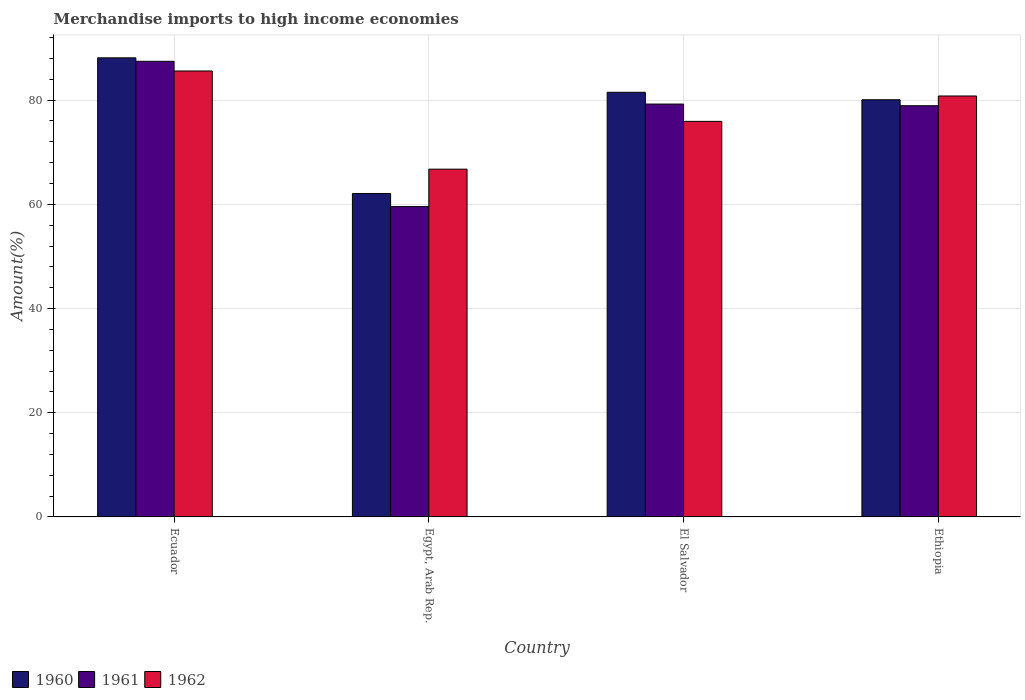Are the number of bars per tick equal to the number of legend labels?
Provide a short and direct response. Yes. Are the number of bars on each tick of the X-axis equal?
Provide a short and direct response. Yes. How many bars are there on the 2nd tick from the left?
Your answer should be very brief. 3. How many bars are there on the 4th tick from the right?
Your answer should be compact. 3. What is the label of the 4th group of bars from the left?
Give a very brief answer. Ethiopia. In how many cases, is the number of bars for a given country not equal to the number of legend labels?
Keep it short and to the point. 0. What is the percentage of amount earned from merchandise imports in 1960 in Egypt, Arab Rep.?
Your response must be concise. 62.08. Across all countries, what is the maximum percentage of amount earned from merchandise imports in 1962?
Provide a short and direct response. 85.59. Across all countries, what is the minimum percentage of amount earned from merchandise imports in 1961?
Ensure brevity in your answer.  59.56. In which country was the percentage of amount earned from merchandise imports in 1962 maximum?
Your answer should be compact. Ecuador. In which country was the percentage of amount earned from merchandise imports in 1962 minimum?
Your answer should be very brief. Egypt, Arab Rep. What is the total percentage of amount earned from merchandise imports in 1962 in the graph?
Provide a short and direct response. 309.06. What is the difference between the percentage of amount earned from merchandise imports in 1960 in El Salvador and that in Ethiopia?
Provide a short and direct response. 1.43. What is the difference between the percentage of amount earned from merchandise imports in 1960 in Ethiopia and the percentage of amount earned from merchandise imports in 1961 in El Salvador?
Provide a succinct answer. 0.83. What is the average percentage of amount earned from merchandise imports in 1960 per country?
Keep it short and to the point. 77.94. What is the difference between the percentage of amount earned from merchandise imports of/in 1961 and percentage of amount earned from merchandise imports of/in 1960 in El Salvador?
Provide a succinct answer. -2.26. In how many countries, is the percentage of amount earned from merchandise imports in 1960 greater than 72 %?
Offer a terse response. 3. What is the ratio of the percentage of amount earned from merchandise imports in 1962 in Ecuador to that in El Salvador?
Ensure brevity in your answer.  1.13. Is the difference between the percentage of amount earned from merchandise imports in 1961 in El Salvador and Ethiopia greater than the difference between the percentage of amount earned from merchandise imports in 1960 in El Salvador and Ethiopia?
Offer a terse response. No. What is the difference between the highest and the second highest percentage of amount earned from merchandise imports in 1960?
Provide a succinct answer. 6.61. What is the difference between the highest and the lowest percentage of amount earned from merchandise imports in 1962?
Your response must be concise. 18.84. What does the 3rd bar from the right in El Salvador represents?
Give a very brief answer. 1960. Are all the bars in the graph horizontal?
Provide a succinct answer. No. How many countries are there in the graph?
Your response must be concise. 4. What is the difference between two consecutive major ticks on the Y-axis?
Keep it short and to the point. 20. Are the values on the major ticks of Y-axis written in scientific E-notation?
Keep it short and to the point. No. Does the graph contain any zero values?
Your answer should be compact. No. Does the graph contain grids?
Provide a short and direct response. Yes. Where does the legend appear in the graph?
Your response must be concise. Bottom left. How many legend labels are there?
Provide a succinct answer. 3. How are the legend labels stacked?
Your answer should be very brief. Horizontal. What is the title of the graph?
Provide a succinct answer. Merchandise imports to high income economies. What is the label or title of the Y-axis?
Offer a terse response. Amount(%). What is the Amount(%) of 1960 in Ecuador?
Ensure brevity in your answer.  88.12. What is the Amount(%) of 1961 in Ecuador?
Offer a very short reply. 87.45. What is the Amount(%) of 1962 in Ecuador?
Offer a terse response. 85.59. What is the Amount(%) in 1960 in Egypt, Arab Rep.?
Provide a succinct answer. 62.08. What is the Amount(%) in 1961 in Egypt, Arab Rep.?
Offer a terse response. 59.56. What is the Amount(%) of 1962 in Egypt, Arab Rep.?
Offer a very short reply. 66.75. What is the Amount(%) of 1960 in El Salvador?
Your answer should be compact. 81.51. What is the Amount(%) in 1961 in El Salvador?
Ensure brevity in your answer.  79.24. What is the Amount(%) of 1962 in El Salvador?
Provide a succinct answer. 75.92. What is the Amount(%) in 1960 in Ethiopia?
Offer a very short reply. 80.07. What is the Amount(%) in 1961 in Ethiopia?
Your answer should be compact. 78.92. What is the Amount(%) in 1962 in Ethiopia?
Provide a short and direct response. 80.8. Across all countries, what is the maximum Amount(%) of 1960?
Give a very brief answer. 88.12. Across all countries, what is the maximum Amount(%) in 1961?
Your answer should be compact. 87.45. Across all countries, what is the maximum Amount(%) in 1962?
Make the answer very short. 85.59. Across all countries, what is the minimum Amount(%) in 1960?
Keep it short and to the point. 62.08. Across all countries, what is the minimum Amount(%) in 1961?
Make the answer very short. 59.56. Across all countries, what is the minimum Amount(%) in 1962?
Provide a short and direct response. 66.75. What is the total Amount(%) of 1960 in the graph?
Ensure brevity in your answer.  311.77. What is the total Amount(%) of 1961 in the graph?
Provide a succinct answer. 305.18. What is the total Amount(%) in 1962 in the graph?
Make the answer very short. 309.06. What is the difference between the Amount(%) in 1960 in Ecuador and that in Egypt, Arab Rep.?
Keep it short and to the point. 26.04. What is the difference between the Amount(%) of 1961 in Ecuador and that in Egypt, Arab Rep.?
Keep it short and to the point. 27.89. What is the difference between the Amount(%) of 1962 in Ecuador and that in Egypt, Arab Rep.?
Provide a succinct answer. 18.84. What is the difference between the Amount(%) of 1960 in Ecuador and that in El Salvador?
Your answer should be very brief. 6.61. What is the difference between the Amount(%) of 1961 in Ecuador and that in El Salvador?
Make the answer very short. 8.21. What is the difference between the Amount(%) in 1962 in Ecuador and that in El Salvador?
Keep it short and to the point. 9.67. What is the difference between the Amount(%) in 1960 in Ecuador and that in Ethiopia?
Keep it short and to the point. 8.05. What is the difference between the Amount(%) in 1961 in Ecuador and that in Ethiopia?
Ensure brevity in your answer.  8.53. What is the difference between the Amount(%) in 1962 in Ecuador and that in Ethiopia?
Give a very brief answer. 4.8. What is the difference between the Amount(%) in 1960 in Egypt, Arab Rep. and that in El Salvador?
Offer a very short reply. -19.43. What is the difference between the Amount(%) of 1961 in Egypt, Arab Rep. and that in El Salvador?
Your response must be concise. -19.68. What is the difference between the Amount(%) in 1962 in Egypt, Arab Rep. and that in El Salvador?
Your answer should be very brief. -9.17. What is the difference between the Amount(%) in 1960 in Egypt, Arab Rep. and that in Ethiopia?
Ensure brevity in your answer.  -17.99. What is the difference between the Amount(%) of 1961 in Egypt, Arab Rep. and that in Ethiopia?
Ensure brevity in your answer.  -19.36. What is the difference between the Amount(%) in 1962 in Egypt, Arab Rep. and that in Ethiopia?
Your response must be concise. -14.05. What is the difference between the Amount(%) of 1960 in El Salvador and that in Ethiopia?
Ensure brevity in your answer.  1.43. What is the difference between the Amount(%) of 1961 in El Salvador and that in Ethiopia?
Your response must be concise. 0.32. What is the difference between the Amount(%) of 1962 in El Salvador and that in Ethiopia?
Your response must be concise. -4.87. What is the difference between the Amount(%) of 1960 in Ecuador and the Amount(%) of 1961 in Egypt, Arab Rep.?
Ensure brevity in your answer.  28.56. What is the difference between the Amount(%) in 1960 in Ecuador and the Amount(%) in 1962 in Egypt, Arab Rep.?
Provide a short and direct response. 21.37. What is the difference between the Amount(%) of 1961 in Ecuador and the Amount(%) of 1962 in Egypt, Arab Rep.?
Provide a succinct answer. 20.7. What is the difference between the Amount(%) of 1960 in Ecuador and the Amount(%) of 1961 in El Salvador?
Your answer should be very brief. 8.88. What is the difference between the Amount(%) in 1960 in Ecuador and the Amount(%) in 1962 in El Salvador?
Your answer should be very brief. 12.2. What is the difference between the Amount(%) of 1961 in Ecuador and the Amount(%) of 1962 in El Salvador?
Your response must be concise. 11.53. What is the difference between the Amount(%) in 1960 in Ecuador and the Amount(%) in 1961 in Ethiopia?
Give a very brief answer. 9.19. What is the difference between the Amount(%) of 1960 in Ecuador and the Amount(%) of 1962 in Ethiopia?
Your answer should be very brief. 7.32. What is the difference between the Amount(%) of 1961 in Ecuador and the Amount(%) of 1962 in Ethiopia?
Keep it short and to the point. 6.65. What is the difference between the Amount(%) of 1960 in Egypt, Arab Rep. and the Amount(%) of 1961 in El Salvador?
Make the answer very short. -17.17. What is the difference between the Amount(%) of 1960 in Egypt, Arab Rep. and the Amount(%) of 1962 in El Salvador?
Your answer should be compact. -13.84. What is the difference between the Amount(%) of 1961 in Egypt, Arab Rep. and the Amount(%) of 1962 in El Salvador?
Keep it short and to the point. -16.36. What is the difference between the Amount(%) of 1960 in Egypt, Arab Rep. and the Amount(%) of 1961 in Ethiopia?
Your answer should be very brief. -16.85. What is the difference between the Amount(%) in 1960 in Egypt, Arab Rep. and the Amount(%) in 1962 in Ethiopia?
Provide a short and direct response. -18.72. What is the difference between the Amount(%) in 1961 in Egypt, Arab Rep. and the Amount(%) in 1962 in Ethiopia?
Provide a succinct answer. -21.23. What is the difference between the Amount(%) of 1960 in El Salvador and the Amount(%) of 1961 in Ethiopia?
Offer a very short reply. 2.58. What is the difference between the Amount(%) in 1960 in El Salvador and the Amount(%) in 1962 in Ethiopia?
Provide a succinct answer. 0.71. What is the difference between the Amount(%) of 1961 in El Salvador and the Amount(%) of 1962 in Ethiopia?
Provide a short and direct response. -1.55. What is the average Amount(%) in 1960 per country?
Give a very brief answer. 77.94. What is the average Amount(%) in 1961 per country?
Give a very brief answer. 76.3. What is the average Amount(%) of 1962 per country?
Make the answer very short. 77.27. What is the difference between the Amount(%) of 1960 and Amount(%) of 1961 in Ecuador?
Provide a short and direct response. 0.67. What is the difference between the Amount(%) in 1960 and Amount(%) in 1962 in Ecuador?
Offer a terse response. 2.53. What is the difference between the Amount(%) in 1961 and Amount(%) in 1962 in Ecuador?
Your response must be concise. 1.86. What is the difference between the Amount(%) of 1960 and Amount(%) of 1961 in Egypt, Arab Rep.?
Provide a short and direct response. 2.51. What is the difference between the Amount(%) of 1960 and Amount(%) of 1962 in Egypt, Arab Rep.?
Give a very brief answer. -4.67. What is the difference between the Amount(%) of 1961 and Amount(%) of 1962 in Egypt, Arab Rep.?
Ensure brevity in your answer.  -7.19. What is the difference between the Amount(%) in 1960 and Amount(%) in 1961 in El Salvador?
Give a very brief answer. 2.26. What is the difference between the Amount(%) in 1960 and Amount(%) in 1962 in El Salvador?
Keep it short and to the point. 5.58. What is the difference between the Amount(%) in 1961 and Amount(%) in 1962 in El Salvador?
Your answer should be very brief. 3.32. What is the difference between the Amount(%) of 1960 and Amount(%) of 1961 in Ethiopia?
Ensure brevity in your answer.  1.15. What is the difference between the Amount(%) in 1960 and Amount(%) in 1962 in Ethiopia?
Offer a very short reply. -0.72. What is the difference between the Amount(%) of 1961 and Amount(%) of 1962 in Ethiopia?
Your response must be concise. -1.87. What is the ratio of the Amount(%) of 1960 in Ecuador to that in Egypt, Arab Rep.?
Make the answer very short. 1.42. What is the ratio of the Amount(%) of 1961 in Ecuador to that in Egypt, Arab Rep.?
Your answer should be compact. 1.47. What is the ratio of the Amount(%) of 1962 in Ecuador to that in Egypt, Arab Rep.?
Offer a very short reply. 1.28. What is the ratio of the Amount(%) of 1960 in Ecuador to that in El Salvador?
Your answer should be compact. 1.08. What is the ratio of the Amount(%) of 1961 in Ecuador to that in El Salvador?
Give a very brief answer. 1.1. What is the ratio of the Amount(%) in 1962 in Ecuador to that in El Salvador?
Give a very brief answer. 1.13. What is the ratio of the Amount(%) of 1960 in Ecuador to that in Ethiopia?
Your response must be concise. 1.1. What is the ratio of the Amount(%) of 1961 in Ecuador to that in Ethiopia?
Provide a succinct answer. 1.11. What is the ratio of the Amount(%) in 1962 in Ecuador to that in Ethiopia?
Make the answer very short. 1.06. What is the ratio of the Amount(%) of 1960 in Egypt, Arab Rep. to that in El Salvador?
Your answer should be very brief. 0.76. What is the ratio of the Amount(%) of 1961 in Egypt, Arab Rep. to that in El Salvador?
Give a very brief answer. 0.75. What is the ratio of the Amount(%) in 1962 in Egypt, Arab Rep. to that in El Salvador?
Provide a short and direct response. 0.88. What is the ratio of the Amount(%) of 1960 in Egypt, Arab Rep. to that in Ethiopia?
Keep it short and to the point. 0.78. What is the ratio of the Amount(%) in 1961 in Egypt, Arab Rep. to that in Ethiopia?
Offer a very short reply. 0.75. What is the ratio of the Amount(%) of 1962 in Egypt, Arab Rep. to that in Ethiopia?
Your answer should be compact. 0.83. What is the ratio of the Amount(%) of 1960 in El Salvador to that in Ethiopia?
Your answer should be very brief. 1.02. What is the ratio of the Amount(%) in 1962 in El Salvador to that in Ethiopia?
Give a very brief answer. 0.94. What is the difference between the highest and the second highest Amount(%) of 1960?
Make the answer very short. 6.61. What is the difference between the highest and the second highest Amount(%) of 1961?
Your response must be concise. 8.21. What is the difference between the highest and the second highest Amount(%) in 1962?
Ensure brevity in your answer.  4.8. What is the difference between the highest and the lowest Amount(%) in 1960?
Offer a terse response. 26.04. What is the difference between the highest and the lowest Amount(%) in 1961?
Your response must be concise. 27.89. What is the difference between the highest and the lowest Amount(%) in 1962?
Offer a terse response. 18.84. 